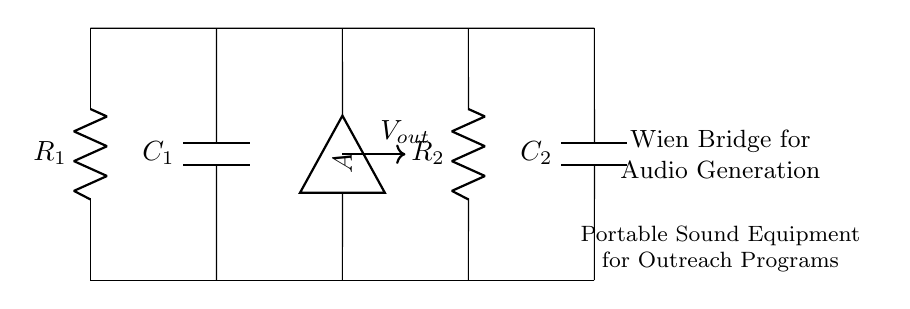What type of circuit is depicted? The circuit is a Wien Bridge circuit, recognizable by its arrangement of resistors and capacitors, used to generate audio frequencies.
Answer: Wien Bridge How many resistors are in the circuit? There are two resistors labeled R1 and R2, which are essential components in determining the frequency of the generated output signal.
Answer: 2 What components in the circuit are capacitors? The components labeled C1 and C2 are capacitors that play a role in the frequency response of the Wien Bridge circuit.
Answer: C1 and C2 What is the purpose of the amplifier in this circuit? The amplifier, labeled with A, increases the output voltage, making it suitable for driving portable sound equipment in outreach programs.
Answer: Increase output voltage How does the frequency of the output signal depend on the resistors and capacitors? The frequency is determined by the values of R1, R2, C1, and C2, where the relationship is given by the formula involving these components in the Wien Bridge configuration.
Answer: Depends on R1, R2, C1, C2 What can be inferred about the overall goal of this circuit design? The circuit is designed to generate audio frequencies specifically for portable sound equipment, indicating an application in outreach programs that require mobility and sound amplification.
Answer: Audio generation for outreach 